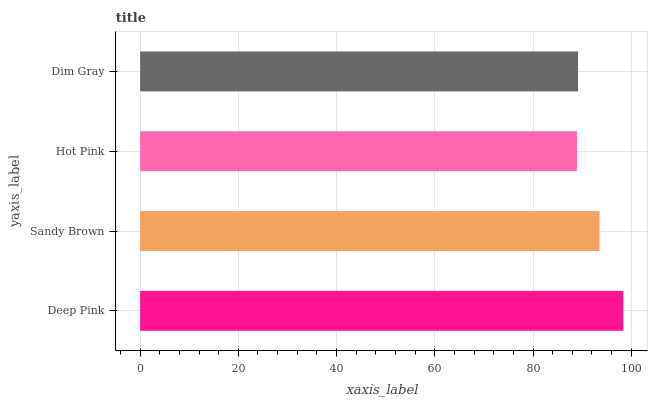Is Hot Pink the minimum?
Answer yes or no. Yes. Is Deep Pink the maximum?
Answer yes or no. Yes. Is Sandy Brown the minimum?
Answer yes or no. No. Is Sandy Brown the maximum?
Answer yes or no. No. Is Deep Pink greater than Sandy Brown?
Answer yes or no. Yes. Is Sandy Brown less than Deep Pink?
Answer yes or no. Yes. Is Sandy Brown greater than Deep Pink?
Answer yes or no. No. Is Deep Pink less than Sandy Brown?
Answer yes or no. No. Is Sandy Brown the high median?
Answer yes or no. Yes. Is Dim Gray the low median?
Answer yes or no. Yes. Is Dim Gray the high median?
Answer yes or no. No. Is Hot Pink the low median?
Answer yes or no. No. 